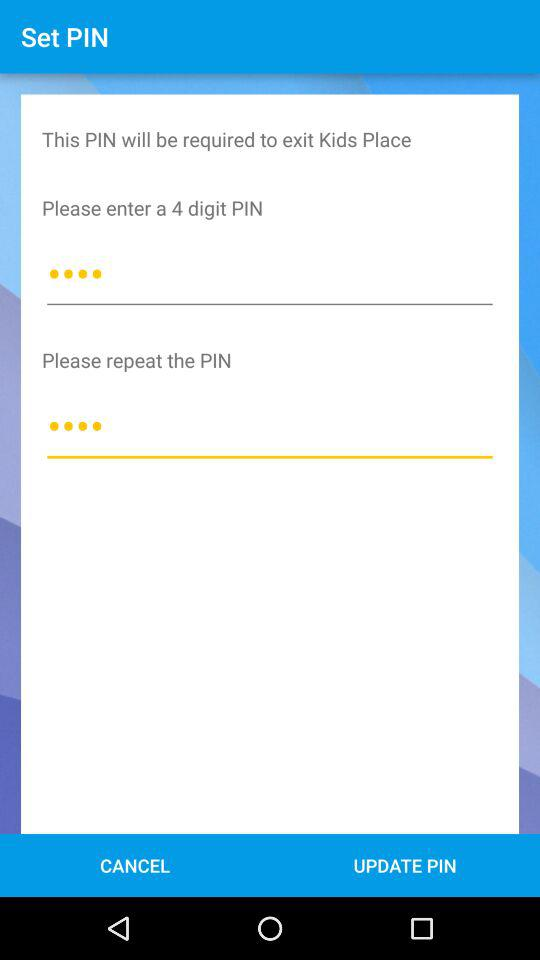How many text inputs do I need to fill out to create a PIN?
Answer the question using a single word or phrase. 2 